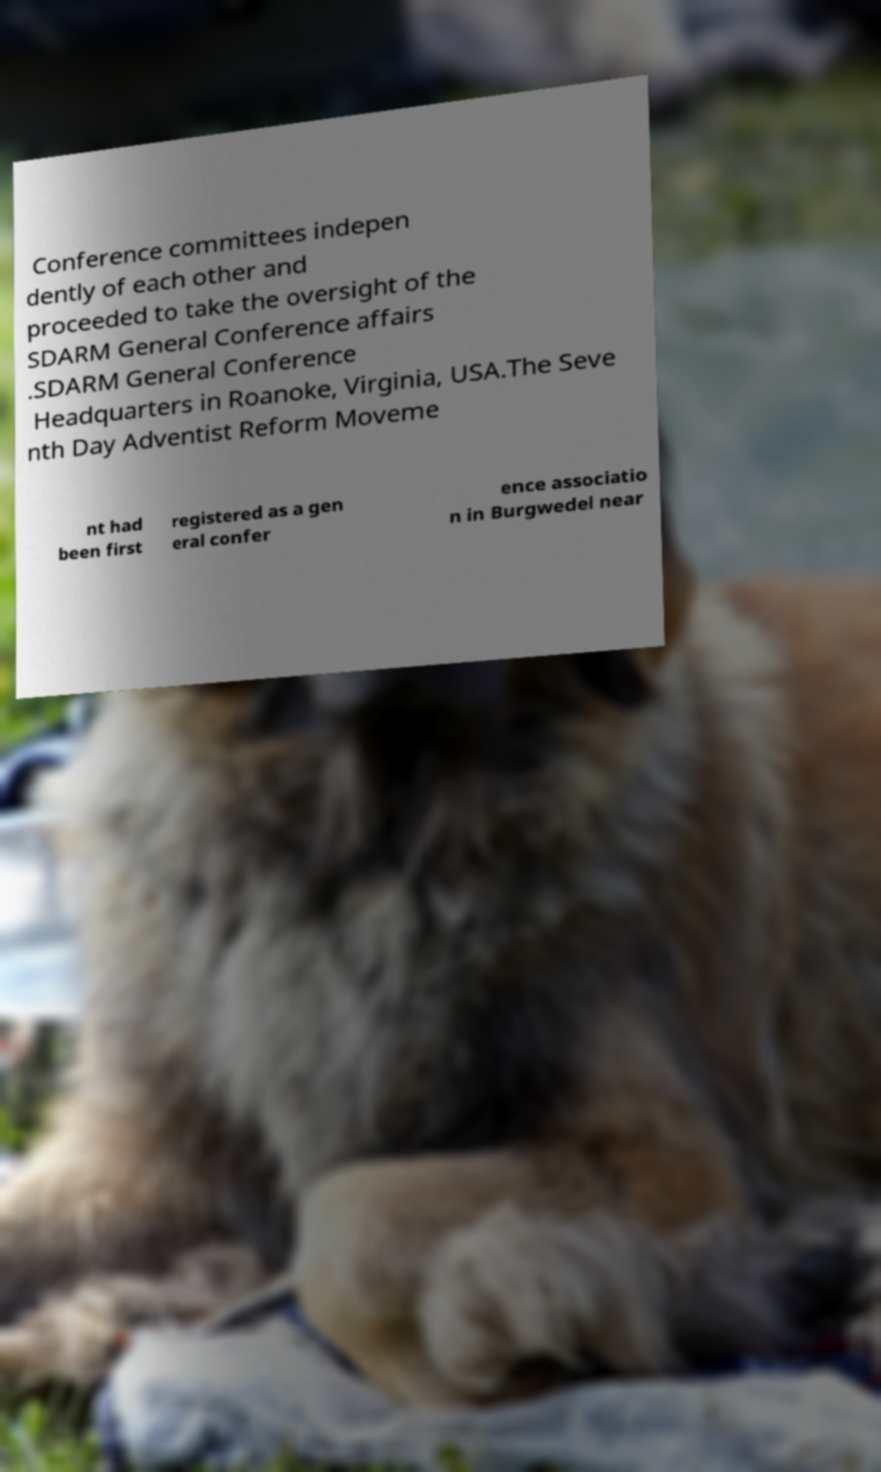Can you read and provide the text displayed in the image?This photo seems to have some interesting text. Can you extract and type it out for me? Conference committees indepen dently of each other and proceeded to take the oversight of the SDARM General Conference affairs .SDARM General Conference Headquarters in Roanoke, Virginia, USA.The Seve nth Day Adventist Reform Moveme nt had been first registered as a gen eral confer ence associatio n in Burgwedel near 